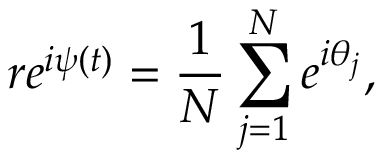Convert formula to latex. <formula><loc_0><loc_0><loc_500><loc_500>r e ^ { i \psi ( t ) } = \frac { 1 } { N } \sum _ { j = 1 } ^ { N } e ^ { i \theta _ { j } } ,</formula> 